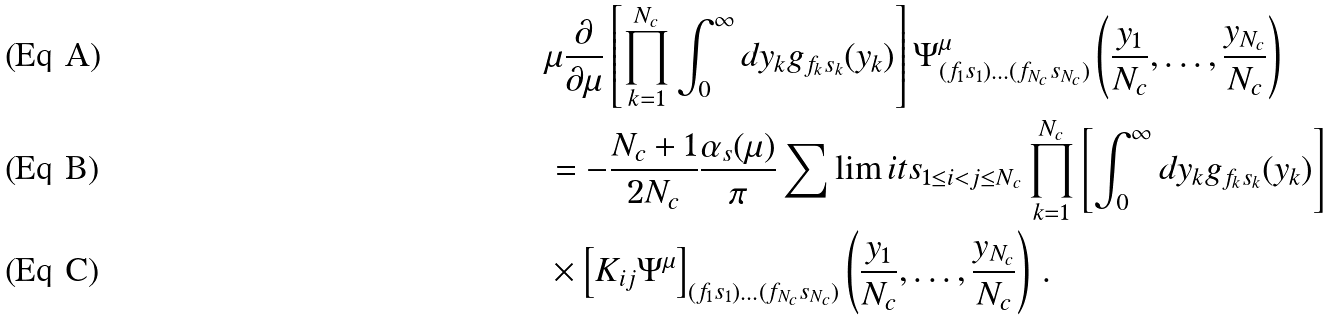<formula> <loc_0><loc_0><loc_500><loc_500>& \mu \frac { \partial } { \partial \mu } \left [ \prod _ { k = 1 } ^ { N _ { c } } \int _ { 0 } ^ { \infty } d y _ { k } g _ { f _ { k } s _ { k } } ( y _ { k } ) \right ] \Psi _ { ( f _ { 1 } s _ { 1 } ) \dots ( f _ { N _ { c } } s _ { N _ { c } } ) } ^ { \mu } \left ( \frac { y _ { 1 } } { N _ { c } } , \dots , \frac { y _ { N _ { c } } } { N _ { c } } \right ) \\ & = - \frac { N _ { c } + 1 } { 2 N _ { c } } \frac { \alpha _ { s } ( \mu ) } { \pi } \sum \lim i t s _ { 1 \leq i < j \leq N _ { c } } \prod _ { k = 1 } ^ { N _ { c } } \left [ \int _ { 0 } ^ { \infty } d y _ { k } g _ { f _ { k } s _ { k } } ( y _ { k } ) \right ] \\ & \times \left [ K _ { i j } \Psi ^ { \mu } \right ] _ { ( f _ { 1 } s _ { 1 } ) \dots ( f _ { N _ { c } } s _ { N _ { c } } ) } \left ( \frac { y _ { 1 } } { N _ { c } } , \dots , \frac { y _ { N _ { c } } } { N _ { c } } \right ) \, .</formula> 